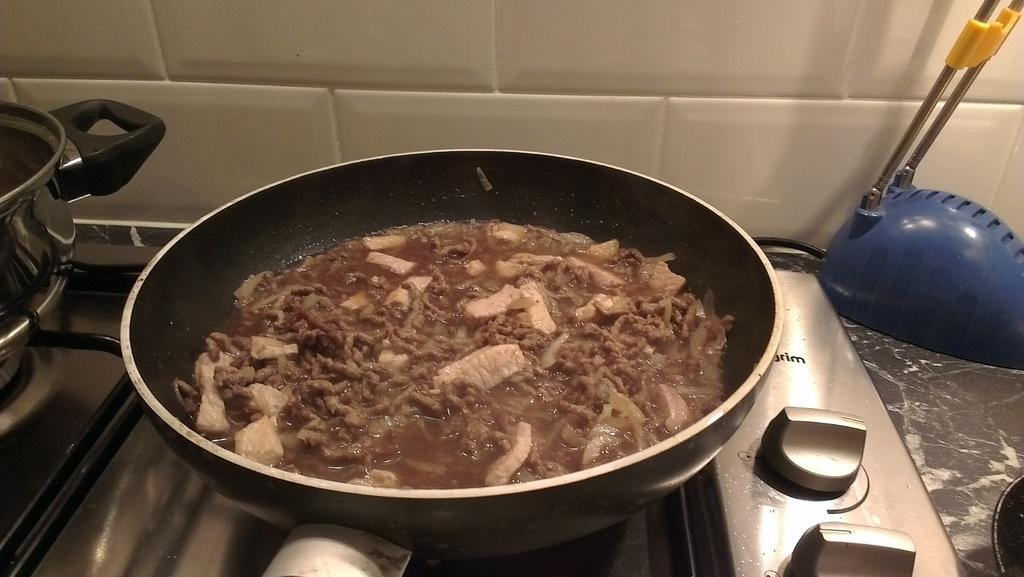What is being cooked in the pan in the image? There is food in a pan in the image. Where is the container located in the image? The container is on the stove in the image. Can you describe the pan in the background of the image? There is a pan on a table in the background of the image. What can be seen in the background of the image? There is a wall visible in the background of the image. How many boys are sitting under the shade in the image? There are no boys or shade present in the image. What type of nerve is being stimulated by the food in the pan? The image does not provide information about the type of nerve being stimulated by the food in the pan. 